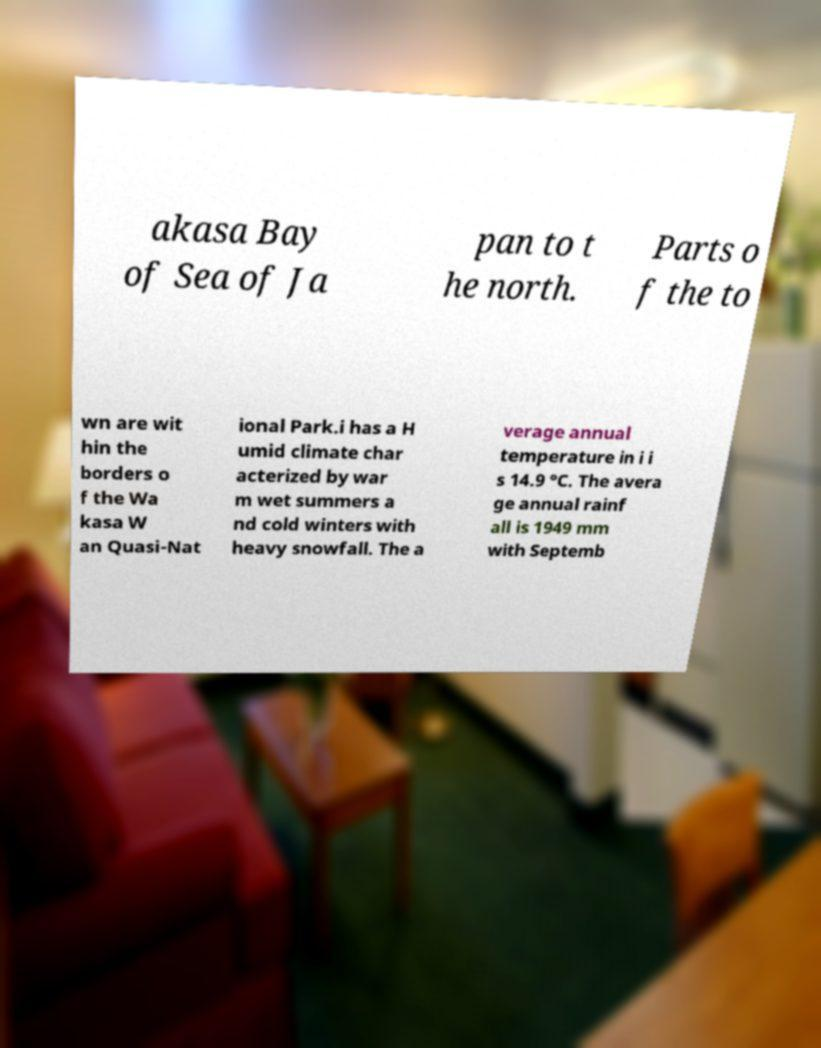Please identify and transcribe the text found in this image. akasa Bay of Sea of Ja pan to t he north. Parts o f the to wn are wit hin the borders o f the Wa kasa W an Quasi-Nat ional Park.i has a H umid climate char acterized by war m wet summers a nd cold winters with heavy snowfall. The a verage annual temperature in i i s 14.9 °C. The avera ge annual rainf all is 1949 mm with Septemb 